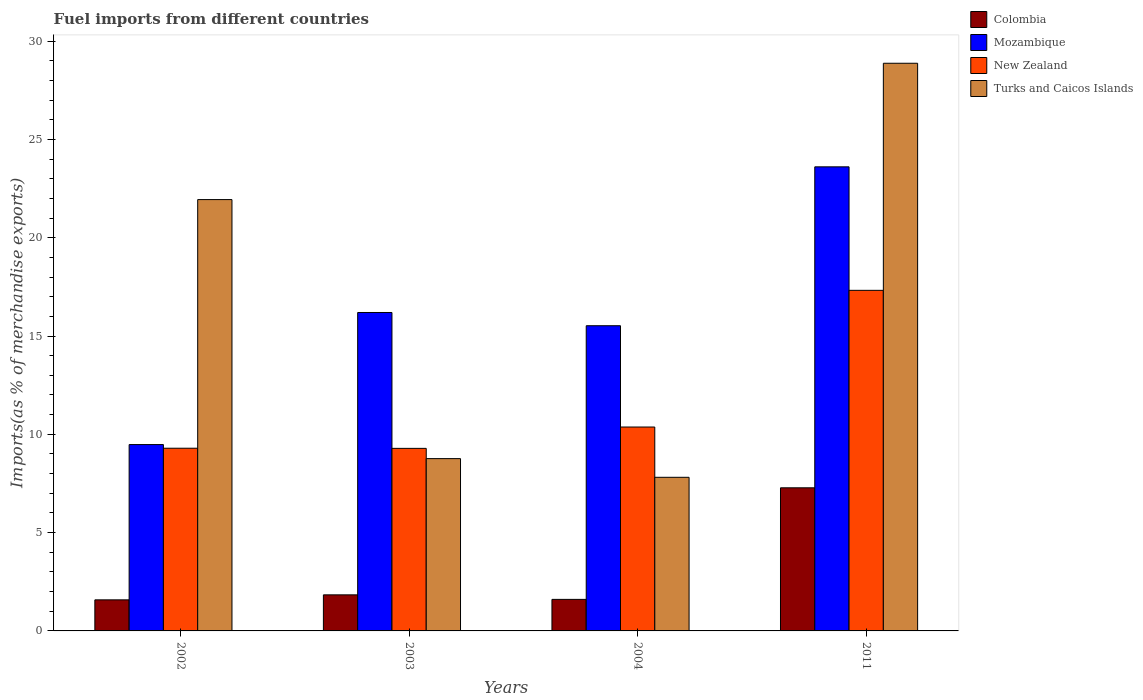How many different coloured bars are there?
Your answer should be very brief. 4. How many groups of bars are there?
Keep it short and to the point. 4. Are the number of bars per tick equal to the number of legend labels?
Provide a succinct answer. Yes. Are the number of bars on each tick of the X-axis equal?
Make the answer very short. Yes. How many bars are there on the 4th tick from the left?
Make the answer very short. 4. In how many cases, is the number of bars for a given year not equal to the number of legend labels?
Your answer should be very brief. 0. What is the percentage of imports to different countries in Mozambique in 2003?
Your response must be concise. 16.2. Across all years, what is the maximum percentage of imports to different countries in New Zealand?
Your answer should be very brief. 17.32. Across all years, what is the minimum percentage of imports to different countries in Mozambique?
Your response must be concise. 9.48. In which year was the percentage of imports to different countries in Turks and Caicos Islands maximum?
Give a very brief answer. 2011. What is the total percentage of imports to different countries in Colombia in the graph?
Offer a very short reply. 12.3. What is the difference between the percentage of imports to different countries in Turks and Caicos Islands in 2004 and that in 2011?
Offer a terse response. -21.06. What is the difference between the percentage of imports to different countries in Turks and Caicos Islands in 2011 and the percentage of imports to different countries in New Zealand in 2004?
Make the answer very short. 18.5. What is the average percentage of imports to different countries in Mozambique per year?
Make the answer very short. 16.2. In the year 2003, what is the difference between the percentage of imports to different countries in Colombia and percentage of imports to different countries in Mozambique?
Your answer should be very brief. -14.36. What is the ratio of the percentage of imports to different countries in Mozambique in 2002 to that in 2003?
Keep it short and to the point. 0.59. Is the difference between the percentage of imports to different countries in Colombia in 2002 and 2003 greater than the difference between the percentage of imports to different countries in Mozambique in 2002 and 2003?
Offer a very short reply. Yes. What is the difference between the highest and the second highest percentage of imports to different countries in New Zealand?
Offer a terse response. 6.95. What is the difference between the highest and the lowest percentage of imports to different countries in New Zealand?
Ensure brevity in your answer.  8.04. Is the sum of the percentage of imports to different countries in Mozambique in 2002 and 2003 greater than the maximum percentage of imports to different countries in Colombia across all years?
Provide a short and direct response. Yes. What does the 3rd bar from the right in 2011 represents?
Ensure brevity in your answer.  Mozambique. Is it the case that in every year, the sum of the percentage of imports to different countries in Turks and Caicos Islands and percentage of imports to different countries in New Zealand is greater than the percentage of imports to different countries in Colombia?
Your response must be concise. Yes. Are all the bars in the graph horizontal?
Offer a terse response. No. How many years are there in the graph?
Ensure brevity in your answer.  4. What is the difference between two consecutive major ticks on the Y-axis?
Give a very brief answer. 5. Are the values on the major ticks of Y-axis written in scientific E-notation?
Offer a terse response. No. Does the graph contain any zero values?
Provide a succinct answer. No. Where does the legend appear in the graph?
Ensure brevity in your answer.  Top right. How many legend labels are there?
Offer a very short reply. 4. What is the title of the graph?
Your answer should be compact. Fuel imports from different countries. Does "Macao" appear as one of the legend labels in the graph?
Offer a terse response. No. What is the label or title of the X-axis?
Give a very brief answer. Years. What is the label or title of the Y-axis?
Ensure brevity in your answer.  Imports(as % of merchandise exports). What is the Imports(as % of merchandise exports) of Colombia in 2002?
Offer a very short reply. 1.58. What is the Imports(as % of merchandise exports) of Mozambique in 2002?
Your answer should be very brief. 9.48. What is the Imports(as % of merchandise exports) of New Zealand in 2002?
Your answer should be compact. 9.29. What is the Imports(as % of merchandise exports) in Turks and Caicos Islands in 2002?
Keep it short and to the point. 21.94. What is the Imports(as % of merchandise exports) in Colombia in 2003?
Offer a very short reply. 1.83. What is the Imports(as % of merchandise exports) in Mozambique in 2003?
Give a very brief answer. 16.2. What is the Imports(as % of merchandise exports) of New Zealand in 2003?
Keep it short and to the point. 9.28. What is the Imports(as % of merchandise exports) in Turks and Caicos Islands in 2003?
Keep it short and to the point. 8.76. What is the Imports(as % of merchandise exports) in Colombia in 2004?
Provide a succinct answer. 1.6. What is the Imports(as % of merchandise exports) in Mozambique in 2004?
Ensure brevity in your answer.  15.52. What is the Imports(as % of merchandise exports) of New Zealand in 2004?
Make the answer very short. 10.37. What is the Imports(as % of merchandise exports) in Turks and Caicos Islands in 2004?
Your response must be concise. 7.81. What is the Imports(as % of merchandise exports) of Colombia in 2011?
Ensure brevity in your answer.  7.28. What is the Imports(as % of merchandise exports) of Mozambique in 2011?
Your answer should be compact. 23.6. What is the Imports(as % of merchandise exports) in New Zealand in 2011?
Ensure brevity in your answer.  17.32. What is the Imports(as % of merchandise exports) of Turks and Caicos Islands in 2011?
Give a very brief answer. 28.87. Across all years, what is the maximum Imports(as % of merchandise exports) in Colombia?
Offer a very short reply. 7.28. Across all years, what is the maximum Imports(as % of merchandise exports) of Mozambique?
Your answer should be compact. 23.6. Across all years, what is the maximum Imports(as % of merchandise exports) in New Zealand?
Ensure brevity in your answer.  17.32. Across all years, what is the maximum Imports(as % of merchandise exports) in Turks and Caicos Islands?
Give a very brief answer. 28.87. Across all years, what is the minimum Imports(as % of merchandise exports) of Colombia?
Provide a succinct answer. 1.58. Across all years, what is the minimum Imports(as % of merchandise exports) of Mozambique?
Ensure brevity in your answer.  9.48. Across all years, what is the minimum Imports(as % of merchandise exports) of New Zealand?
Provide a short and direct response. 9.28. Across all years, what is the minimum Imports(as % of merchandise exports) of Turks and Caicos Islands?
Your answer should be very brief. 7.81. What is the total Imports(as % of merchandise exports) in Colombia in the graph?
Give a very brief answer. 12.3. What is the total Imports(as % of merchandise exports) of Mozambique in the graph?
Your answer should be compact. 64.8. What is the total Imports(as % of merchandise exports) of New Zealand in the graph?
Provide a succinct answer. 46.27. What is the total Imports(as % of merchandise exports) in Turks and Caicos Islands in the graph?
Your answer should be compact. 67.39. What is the difference between the Imports(as % of merchandise exports) of Colombia in 2002 and that in 2003?
Your response must be concise. -0.25. What is the difference between the Imports(as % of merchandise exports) in Mozambique in 2002 and that in 2003?
Provide a succinct answer. -6.72. What is the difference between the Imports(as % of merchandise exports) of New Zealand in 2002 and that in 2003?
Your answer should be very brief. 0.01. What is the difference between the Imports(as % of merchandise exports) in Turks and Caicos Islands in 2002 and that in 2003?
Keep it short and to the point. 13.18. What is the difference between the Imports(as % of merchandise exports) in Colombia in 2002 and that in 2004?
Your answer should be compact. -0.02. What is the difference between the Imports(as % of merchandise exports) of Mozambique in 2002 and that in 2004?
Keep it short and to the point. -6.04. What is the difference between the Imports(as % of merchandise exports) of New Zealand in 2002 and that in 2004?
Your response must be concise. -1.08. What is the difference between the Imports(as % of merchandise exports) of Turks and Caicos Islands in 2002 and that in 2004?
Ensure brevity in your answer.  14.13. What is the difference between the Imports(as % of merchandise exports) in Colombia in 2002 and that in 2011?
Your answer should be very brief. -5.7. What is the difference between the Imports(as % of merchandise exports) in Mozambique in 2002 and that in 2011?
Provide a succinct answer. -14.13. What is the difference between the Imports(as % of merchandise exports) in New Zealand in 2002 and that in 2011?
Make the answer very short. -8.03. What is the difference between the Imports(as % of merchandise exports) of Turks and Caicos Islands in 2002 and that in 2011?
Give a very brief answer. -6.93. What is the difference between the Imports(as % of merchandise exports) of Colombia in 2003 and that in 2004?
Keep it short and to the point. 0.23. What is the difference between the Imports(as % of merchandise exports) of Mozambique in 2003 and that in 2004?
Make the answer very short. 0.67. What is the difference between the Imports(as % of merchandise exports) of New Zealand in 2003 and that in 2004?
Offer a terse response. -1.09. What is the difference between the Imports(as % of merchandise exports) of Colombia in 2003 and that in 2011?
Your response must be concise. -5.44. What is the difference between the Imports(as % of merchandise exports) in Mozambique in 2003 and that in 2011?
Make the answer very short. -7.41. What is the difference between the Imports(as % of merchandise exports) of New Zealand in 2003 and that in 2011?
Provide a short and direct response. -8.04. What is the difference between the Imports(as % of merchandise exports) of Turks and Caicos Islands in 2003 and that in 2011?
Keep it short and to the point. -20.11. What is the difference between the Imports(as % of merchandise exports) in Colombia in 2004 and that in 2011?
Provide a short and direct response. -5.67. What is the difference between the Imports(as % of merchandise exports) in Mozambique in 2004 and that in 2011?
Make the answer very short. -8.08. What is the difference between the Imports(as % of merchandise exports) of New Zealand in 2004 and that in 2011?
Your answer should be compact. -6.95. What is the difference between the Imports(as % of merchandise exports) of Turks and Caicos Islands in 2004 and that in 2011?
Offer a terse response. -21.06. What is the difference between the Imports(as % of merchandise exports) in Colombia in 2002 and the Imports(as % of merchandise exports) in Mozambique in 2003?
Your response must be concise. -14.62. What is the difference between the Imports(as % of merchandise exports) of Colombia in 2002 and the Imports(as % of merchandise exports) of New Zealand in 2003?
Provide a succinct answer. -7.71. What is the difference between the Imports(as % of merchandise exports) in Colombia in 2002 and the Imports(as % of merchandise exports) in Turks and Caicos Islands in 2003?
Give a very brief answer. -7.18. What is the difference between the Imports(as % of merchandise exports) of Mozambique in 2002 and the Imports(as % of merchandise exports) of New Zealand in 2003?
Give a very brief answer. 0.19. What is the difference between the Imports(as % of merchandise exports) of Mozambique in 2002 and the Imports(as % of merchandise exports) of Turks and Caicos Islands in 2003?
Keep it short and to the point. 0.71. What is the difference between the Imports(as % of merchandise exports) in New Zealand in 2002 and the Imports(as % of merchandise exports) in Turks and Caicos Islands in 2003?
Offer a terse response. 0.53. What is the difference between the Imports(as % of merchandise exports) in Colombia in 2002 and the Imports(as % of merchandise exports) in Mozambique in 2004?
Make the answer very short. -13.94. What is the difference between the Imports(as % of merchandise exports) in Colombia in 2002 and the Imports(as % of merchandise exports) in New Zealand in 2004?
Offer a very short reply. -8.79. What is the difference between the Imports(as % of merchandise exports) of Colombia in 2002 and the Imports(as % of merchandise exports) of Turks and Caicos Islands in 2004?
Your answer should be compact. -6.23. What is the difference between the Imports(as % of merchandise exports) in Mozambique in 2002 and the Imports(as % of merchandise exports) in New Zealand in 2004?
Provide a succinct answer. -0.89. What is the difference between the Imports(as % of merchandise exports) of Mozambique in 2002 and the Imports(as % of merchandise exports) of Turks and Caicos Islands in 2004?
Your answer should be compact. 1.66. What is the difference between the Imports(as % of merchandise exports) of New Zealand in 2002 and the Imports(as % of merchandise exports) of Turks and Caicos Islands in 2004?
Ensure brevity in your answer.  1.48. What is the difference between the Imports(as % of merchandise exports) of Colombia in 2002 and the Imports(as % of merchandise exports) of Mozambique in 2011?
Give a very brief answer. -22.02. What is the difference between the Imports(as % of merchandise exports) in Colombia in 2002 and the Imports(as % of merchandise exports) in New Zealand in 2011?
Ensure brevity in your answer.  -15.74. What is the difference between the Imports(as % of merchandise exports) of Colombia in 2002 and the Imports(as % of merchandise exports) of Turks and Caicos Islands in 2011?
Offer a very short reply. -27.29. What is the difference between the Imports(as % of merchandise exports) of Mozambique in 2002 and the Imports(as % of merchandise exports) of New Zealand in 2011?
Offer a very short reply. -7.85. What is the difference between the Imports(as % of merchandise exports) of Mozambique in 2002 and the Imports(as % of merchandise exports) of Turks and Caicos Islands in 2011?
Provide a short and direct response. -19.39. What is the difference between the Imports(as % of merchandise exports) in New Zealand in 2002 and the Imports(as % of merchandise exports) in Turks and Caicos Islands in 2011?
Ensure brevity in your answer.  -19.58. What is the difference between the Imports(as % of merchandise exports) in Colombia in 2003 and the Imports(as % of merchandise exports) in Mozambique in 2004?
Provide a short and direct response. -13.69. What is the difference between the Imports(as % of merchandise exports) of Colombia in 2003 and the Imports(as % of merchandise exports) of New Zealand in 2004?
Give a very brief answer. -8.54. What is the difference between the Imports(as % of merchandise exports) in Colombia in 2003 and the Imports(as % of merchandise exports) in Turks and Caicos Islands in 2004?
Your response must be concise. -5.98. What is the difference between the Imports(as % of merchandise exports) in Mozambique in 2003 and the Imports(as % of merchandise exports) in New Zealand in 2004?
Your response must be concise. 5.83. What is the difference between the Imports(as % of merchandise exports) of Mozambique in 2003 and the Imports(as % of merchandise exports) of Turks and Caicos Islands in 2004?
Ensure brevity in your answer.  8.38. What is the difference between the Imports(as % of merchandise exports) in New Zealand in 2003 and the Imports(as % of merchandise exports) in Turks and Caicos Islands in 2004?
Keep it short and to the point. 1.47. What is the difference between the Imports(as % of merchandise exports) of Colombia in 2003 and the Imports(as % of merchandise exports) of Mozambique in 2011?
Provide a short and direct response. -21.77. What is the difference between the Imports(as % of merchandise exports) in Colombia in 2003 and the Imports(as % of merchandise exports) in New Zealand in 2011?
Provide a succinct answer. -15.49. What is the difference between the Imports(as % of merchandise exports) in Colombia in 2003 and the Imports(as % of merchandise exports) in Turks and Caicos Islands in 2011?
Offer a very short reply. -27.04. What is the difference between the Imports(as % of merchandise exports) in Mozambique in 2003 and the Imports(as % of merchandise exports) in New Zealand in 2011?
Make the answer very short. -1.13. What is the difference between the Imports(as % of merchandise exports) in Mozambique in 2003 and the Imports(as % of merchandise exports) in Turks and Caicos Islands in 2011?
Provide a succinct answer. -12.68. What is the difference between the Imports(as % of merchandise exports) of New Zealand in 2003 and the Imports(as % of merchandise exports) of Turks and Caicos Islands in 2011?
Keep it short and to the point. -19.59. What is the difference between the Imports(as % of merchandise exports) of Colombia in 2004 and the Imports(as % of merchandise exports) of Mozambique in 2011?
Provide a short and direct response. -22. What is the difference between the Imports(as % of merchandise exports) in Colombia in 2004 and the Imports(as % of merchandise exports) in New Zealand in 2011?
Your response must be concise. -15.72. What is the difference between the Imports(as % of merchandise exports) in Colombia in 2004 and the Imports(as % of merchandise exports) in Turks and Caicos Islands in 2011?
Give a very brief answer. -27.27. What is the difference between the Imports(as % of merchandise exports) of Mozambique in 2004 and the Imports(as % of merchandise exports) of New Zealand in 2011?
Offer a terse response. -1.8. What is the difference between the Imports(as % of merchandise exports) of Mozambique in 2004 and the Imports(as % of merchandise exports) of Turks and Caicos Islands in 2011?
Offer a very short reply. -13.35. What is the difference between the Imports(as % of merchandise exports) of New Zealand in 2004 and the Imports(as % of merchandise exports) of Turks and Caicos Islands in 2011?
Your answer should be very brief. -18.5. What is the average Imports(as % of merchandise exports) in Colombia per year?
Your answer should be very brief. 3.07. What is the average Imports(as % of merchandise exports) in Mozambique per year?
Offer a very short reply. 16.2. What is the average Imports(as % of merchandise exports) in New Zealand per year?
Keep it short and to the point. 11.57. What is the average Imports(as % of merchandise exports) of Turks and Caicos Islands per year?
Your answer should be very brief. 16.85. In the year 2002, what is the difference between the Imports(as % of merchandise exports) in Colombia and Imports(as % of merchandise exports) in Mozambique?
Your answer should be compact. -7.9. In the year 2002, what is the difference between the Imports(as % of merchandise exports) of Colombia and Imports(as % of merchandise exports) of New Zealand?
Offer a very short reply. -7.71. In the year 2002, what is the difference between the Imports(as % of merchandise exports) of Colombia and Imports(as % of merchandise exports) of Turks and Caicos Islands?
Provide a short and direct response. -20.36. In the year 2002, what is the difference between the Imports(as % of merchandise exports) in Mozambique and Imports(as % of merchandise exports) in New Zealand?
Keep it short and to the point. 0.19. In the year 2002, what is the difference between the Imports(as % of merchandise exports) in Mozambique and Imports(as % of merchandise exports) in Turks and Caicos Islands?
Provide a succinct answer. -12.46. In the year 2002, what is the difference between the Imports(as % of merchandise exports) of New Zealand and Imports(as % of merchandise exports) of Turks and Caicos Islands?
Give a very brief answer. -12.65. In the year 2003, what is the difference between the Imports(as % of merchandise exports) of Colombia and Imports(as % of merchandise exports) of Mozambique?
Make the answer very short. -14.36. In the year 2003, what is the difference between the Imports(as % of merchandise exports) in Colombia and Imports(as % of merchandise exports) in New Zealand?
Your response must be concise. -7.45. In the year 2003, what is the difference between the Imports(as % of merchandise exports) of Colombia and Imports(as % of merchandise exports) of Turks and Caicos Islands?
Ensure brevity in your answer.  -6.93. In the year 2003, what is the difference between the Imports(as % of merchandise exports) of Mozambique and Imports(as % of merchandise exports) of New Zealand?
Your response must be concise. 6.91. In the year 2003, what is the difference between the Imports(as % of merchandise exports) in Mozambique and Imports(as % of merchandise exports) in Turks and Caicos Islands?
Make the answer very short. 7.43. In the year 2003, what is the difference between the Imports(as % of merchandise exports) in New Zealand and Imports(as % of merchandise exports) in Turks and Caicos Islands?
Make the answer very short. 0.52. In the year 2004, what is the difference between the Imports(as % of merchandise exports) of Colombia and Imports(as % of merchandise exports) of Mozambique?
Your answer should be very brief. -13.92. In the year 2004, what is the difference between the Imports(as % of merchandise exports) of Colombia and Imports(as % of merchandise exports) of New Zealand?
Offer a very short reply. -8.77. In the year 2004, what is the difference between the Imports(as % of merchandise exports) of Colombia and Imports(as % of merchandise exports) of Turks and Caicos Islands?
Offer a very short reply. -6.21. In the year 2004, what is the difference between the Imports(as % of merchandise exports) of Mozambique and Imports(as % of merchandise exports) of New Zealand?
Give a very brief answer. 5.15. In the year 2004, what is the difference between the Imports(as % of merchandise exports) in Mozambique and Imports(as % of merchandise exports) in Turks and Caicos Islands?
Ensure brevity in your answer.  7.71. In the year 2004, what is the difference between the Imports(as % of merchandise exports) of New Zealand and Imports(as % of merchandise exports) of Turks and Caicos Islands?
Offer a very short reply. 2.56. In the year 2011, what is the difference between the Imports(as % of merchandise exports) in Colombia and Imports(as % of merchandise exports) in Mozambique?
Offer a terse response. -16.32. In the year 2011, what is the difference between the Imports(as % of merchandise exports) in Colombia and Imports(as % of merchandise exports) in New Zealand?
Offer a very short reply. -10.04. In the year 2011, what is the difference between the Imports(as % of merchandise exports) of Colombia and Imports(as % of merchandise exports) of Turks and Caicos Islands?
Offer a very short reply. -21.59. In the year 2011, what is the difference between the Imports(as % of merchandise exports) of Mozambique and Imports(as % of merchandise exports) of New Zealand?
Give a very brief answer. 6.28. In the year 2011, what is the difference between the Imports(as % of merchandise exports) in Mozambique and Imports(as % of merchandise exports) in Turks and Caicos Islands?
Your answer should be very brief. -5.27. In the year 2011, what is the difference between the Imports(as % of merchandise exports) of New Zealand and Imports(as % of merchandise exports) of Turks and Caicos Islands?
Offer a very short reply. -11.55. What is the ratio of the Imports(as % of merchandise exports) of Colombia in 2002 to that in 2003?
Ensure brevity in your answer.  0.86. What is the ratio of the Imports(as % of merchandise exports) of Mozambique in 2002 to that in 2003?
Ensure brevity in your answer.  0.59. What is the ratio of the Imports(as % of merchandise exports) in New Zealand in 2002 to that in 2003?
Offer a very short reply. 1. What is the ratio of the Imports(as % of merchandise exports) of Turks and Caicos Islands in 2002 to that in 2003?
Make the answer very short. 2.5. What is the ratio of the Imports(as % of merchandise exports) of Colombia in 2002 to that in 2004?
Provide a succinct answer. 0.98. What is the ratio of the Imports(as % of merchandise exports) in Mozambique in 2002 to that in 2004?
Your answer should be very brief. 0.61. What is the ratio of the Imports(as % of merchandise exports) in New Zealand in 2002 to that in 2004?
Offer a very short reply. 0.9. What is the ratio of the Imports(as % of merchandise exports) in Turks and Caicos Islands in 2002 to that in 2004?
Provide a succinct answer. 2.81. What is the ratio of the Imports(as % of merchandise exports) of Colombia in 2002 to that in 2011?
Give a very brief answer. 0.22. What is the ratio of the Imports(as % of merchandise exports) in Mozambique in 2002 to that in 2011?
Your answer should be very brief. 0.4. What is the ratio of the Imports(as % of merchandise exports) in New Zealand in 2002 to that in 2011?
Provide a short and direct response. 0.54. What is the ratio of the Imports(as % of merchandise exports) in Turks and Caicos Islands in 2002 to that in 2011?
Your answer should be very brief. 0.76. What is the ratio of the Imports(as % of merchandise exports) in Colombia in 2003 to that in 2004?
Offer a very short reply. 1.14. What is the ratio of the Imports(as % of merchandise exports) in Mozambique in 2003 to that in 2004?
Offer a terse response. 1.04. What is the ratio of the Imports(as % of merchandise exports) of New Zealand in 2003 to that in 2004?
Your response must be concise. 0.9. What is the ratio of the Imports(as % of merchandise exports) of Turks and Caicos Islands in 2003 to that in 2004?
Keep it short and to the point. 1.12. What is the ratio of the Imports(as % of merchandise exports) of Colombia in 2003 to that in 2011?
Give a very brief answer. 0.25. What is the ratio of the Imports(as % of merchandise exports) of Mozambique in 2003 to that in 2011?
Offer a terse response. 0.69. What is the ratio of the Imports(as % of merchandise exports) of New Zealand in 2003 to that in 2011?
Make the answer very short. 0.54. What is the ratio of the Imports(as % of merchandise exports) of Turks and Caicos Islands in 2003 to that in 2011?
Give a very brief answer. 0.3. What is the ratio of the Imports(as % of merchandise exports) of Colombia in 2004 to that in 2011?
Your answer should be very brief. 0.22. What is the ratio of the Imports(as % of merchandise exports) of Mozambique in 2004 to that in 2011?
Make the answer very short. 0.66. What is the ratio of the Imports(as % of merchandise exports) in New Zealand in 2004 to that in 2011?
Your answer should be compact. 0.6. What is the ratio of the Imports(as % of merchandise exports) in Turks and Caicos Islands in 2004 to that in 2011?
Your response must be concise. 0.27. What is the difference between the highest and the second highest Imports(as % of merchandise exports) in Colombia?
Ensure brevity in your answer.  5.44. What is the difference between the highest and the second highest Imports(as % of merchandise exports) in Mozambique?
Keep it short and to the point. 7.41. What is the difference between the highest and the second highest Imports(as % of merchandise exports) of New Zealand?
Your response must be concise. 6.95. What is the difference between the highest and the second highest Imports(as % of merchandise exports) in Turks and Caicos Islands?
Ensure brevity in your answer.  6.93. What is the difference between the highest and the lowest Imports(as % of merchandise exports) of Colombia?
Make the answer very short. 5.7. What is the difference between the highest and the lowest Imports(as % of merchandise exports) of Mozambique?
Ensure brevity in your answer.  14.13. What is the difference between the highest and the lowest Imports(as % of merchandise exports) in New Zealand?
Keep it short and to the point. 8.04. What is the difference between the highest and the lowest Imports(as % of merchandise exports) of Turks and Caicos Islands?
Offer a very short reply. 21.06. 